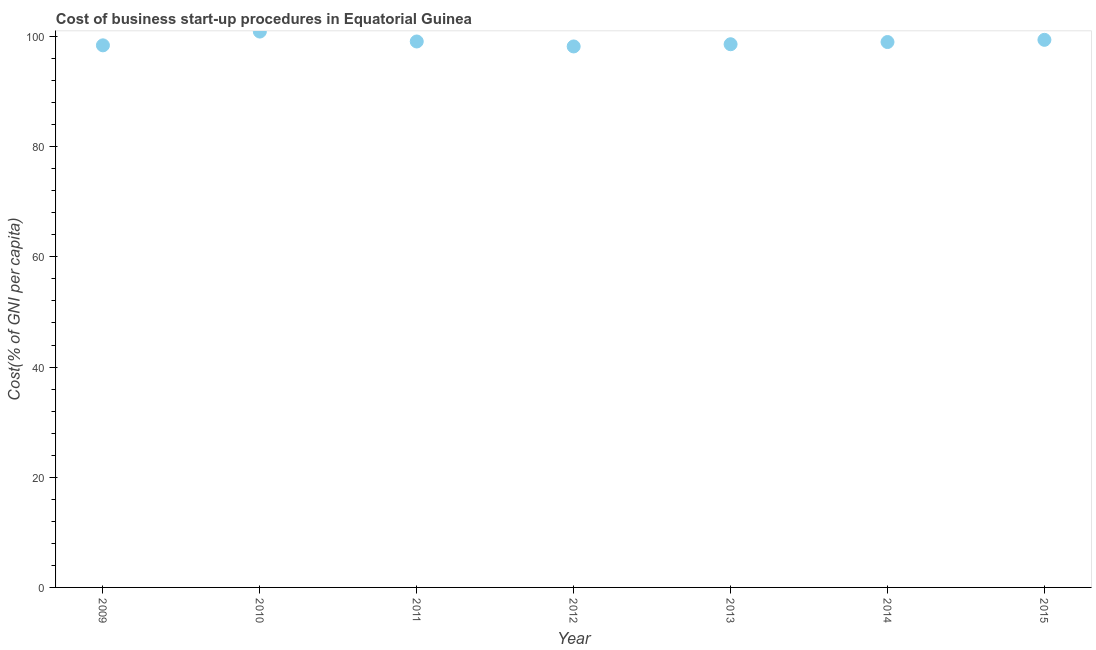What is the cost of business startup procedures in 2013?
Make the answer very short. 98.6. Across all years, what is the maximum cost of business startup procedures?
Offer a terse response. 100.9. Across all years, what is the minimum cost of business startup procedures?
Ensure brevity in your answer.  98.2. What is the sum of the cost of business startup procedures?
Keep it short and to the point. 693.6. What is the difference between the cost of business startup procedures in 2013 and 2014?
Your answer should be very brief. -0.4. What is the average cost of business startup procedures per year?
Offer a very short reply. 99.09. In how many years, is the cost of business startup procedures greater than 44 %?
Your response must be concise. 7. Do a majority of the years between 2010 and 2014 (inclusive) have cost of business startup procedures greater than 84 %?
Your answer should be very brief. Yes. What is the ratio of the cost of business startup procedures in 2011 to that in 2013?
Your response must be concise. 1.01. Is the difference between the cost of business startup procedures in 2010 and 2015 greater than the difference between any two years?
Offer a terse response. No. What is the difference between the highest and the second highest cost of business startup procedures?
Offer a very short reply. 1.5. What is the difference between the highest and the lowest cost of business startup procedures?
Ensure brevity in your answer.  2.7. Does the graph contain grids?
Provide a succinct answer. No. What is the title of the graph?
Provide a short and direct response. Cost of business start-up procedures in Equatorial Guinea. What is the label or title of the X-axis?
Provide a succinct answer. Year. What is the label or title of the Y-axis?
Provide a succinct answer. Cost(% of GNI per capita). What is the Cost(% of GNI per capita) in 2009?
Give a very brief answer. 98.4. What is the Cost(% of GNI per capita) in 2010?
Give a very brief answer. 100.9. What is the Cost(% of GNI per capita) in 2011?
Provide a succinct answer. 99.1. What is the Cost(% of GNI per capita) in 2012?
Provide a short and direct response. 98.2. What is the Cost(% of GNI per capita) in 2013?
Provide a succinct answer. 98.6. What is the Cost(% of GNI per capita) in 2014?
Your answer should be very brief. 99. What is the Cost(% of GNI per capita) in 2015?
Your answer should be very brief. 99.4. What is the difference between the Cost(% of GNI per capita) in 2009 and 2010?
Offer a terse response. -2.5. What is the difference between the Cost(% of GNI per capita) in 2009 and 2011?
Provide a succinct answer. -0.7. What is the difference between the Cost(% of GNI per capita) in 2009 and 2013?
Provide a succinct answer. -0.2. What is the difference between the Cost(% of GNI per capita) in 2009 and 2014?
Your answer should be very brief. -0.6. What is the difference between the Cost(% of GNI per capita) in 2010 and 2011?
Offer a terse response. 1.8. What is the difference between the Cost(% of GNI per capita) in 2010 and 2013?
Your response must be concise. 2.3. What is the difference between the Cost(% of GNI per capita) in 2010 and 2015?
Make the answer very short. 1.5. What is the difference between the Cost(% of GNI per capita) in 2011 and 2012?
Provide a succinct answer. 0.9. What is the ratio of the Cost(% of GNI per capita) in 2009 to that in 2011?
Your response must be concise. 0.99. What is the ratio of the Cost(% of GNI per capita) in 2009 to that in 2012?
Provide a succinct answer. 1. What is the ratio of the Cost(% of GNI per capita) in 2009 to that in 2015?
Your answer should be compact. 0.99. What is the ratio of the Cost(% of GNI per capita) in 2010 to that in 2011?
Make the answer very short. 1.02. What is the ratio of the Cost(% of GNI per capita) in 2010 to that in 2013?
Ensure brevity in your answer.  1.02. What is the ratio of the Cost(% of GNI per capita) in 2010 to that in 2014?
Provide a succinct answer. 1.02. What is the ratio of the Cost(% of GNI per capita) in 2010 to that in 2015?
Give a very brief answer. 1.01. What is the ratio of the Cost(% of GNI per capita) in 2011 to that in 2013?
Offer a very short reply. 1. What is the ratio of the Cost(% of GNI per capita) in 2011 to that in 2015?
Make the answer very short. 1. What is the ratio of the Cost(% of GNI per capita) in 2012 to that in 2014?
Offer a terse response. 0.99. What is the ratio of the Cost(% of GNI per capita) in 2013 to that in 2014?
Your answer should be compact. 1. What is the ratio of the Cost(% of GNI per capita) in 2013 to that in 2015?
Ensure brevity in your answer.  0.99. What is the ratio of the Cost(% of GNI per capita) in 2014 to that in 2015?
Your answer should be compact. 1. 